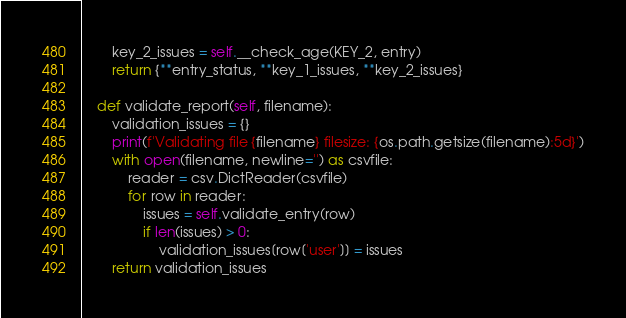Convert code to text. <code><loc_0><loc_0><loc_500><loc_500><_Python_>        key_2_issues = self.__check_age(KEY_2, entry)
        return {**entry_status, **key_1_issues, **key_2_issues}

    def validate_report(self, filename):
        validation_issues = {}
        print(f'Validating file {filename} filesize: {os.path.getsize(filename):5d}')
        with open(filename, newline='') as csvfile:
            reader = csv.DictReader(csvfile)
            for row in reader:
                issues = self.validate_entry(row)
                if len(issues) > 0:
                    validation_issues[row['user']] = issues
        return validation_issues



</code> 